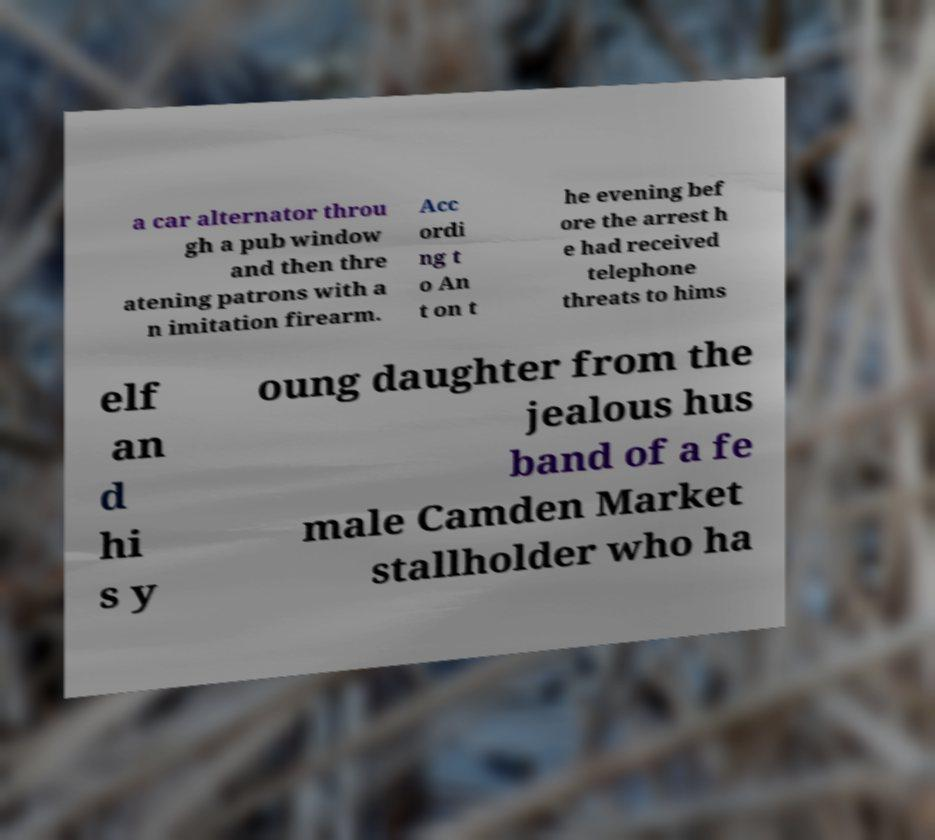Can you read and provide the text displayed in the image?This photo seems to have some interesting text. Can you extract and type it out for me? a car alternator throu gh a pub window and then thre atening patrons with a n imitation firearm. Acc ordi ng t o An t on t he evening bef ore the arrest h e had received telephone threats to hims elf an d hi s y oung daughter from the jealous hus band of a fe male Camden Market stallholder who ha 